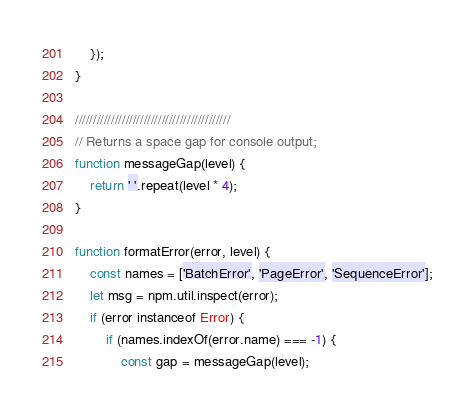<code> <loc_0><loc_0><loc_500><loc_500><_JavaScript_>    });
}

///////////////////////////////////////////
// Returns a space gap for console output;
function messageGap(level) {
    return ' '.repeat(level * 4);
}

function formatError(error, level) {
    const names = ['BatchError', 'PageError', 'SequenceError'];
    let msg = npm.util.inspect(error);
    if (error instanceof Error) {
        if (names.indexOf(error.name) === -1) {
            const gap = messageGap(level);</code> 